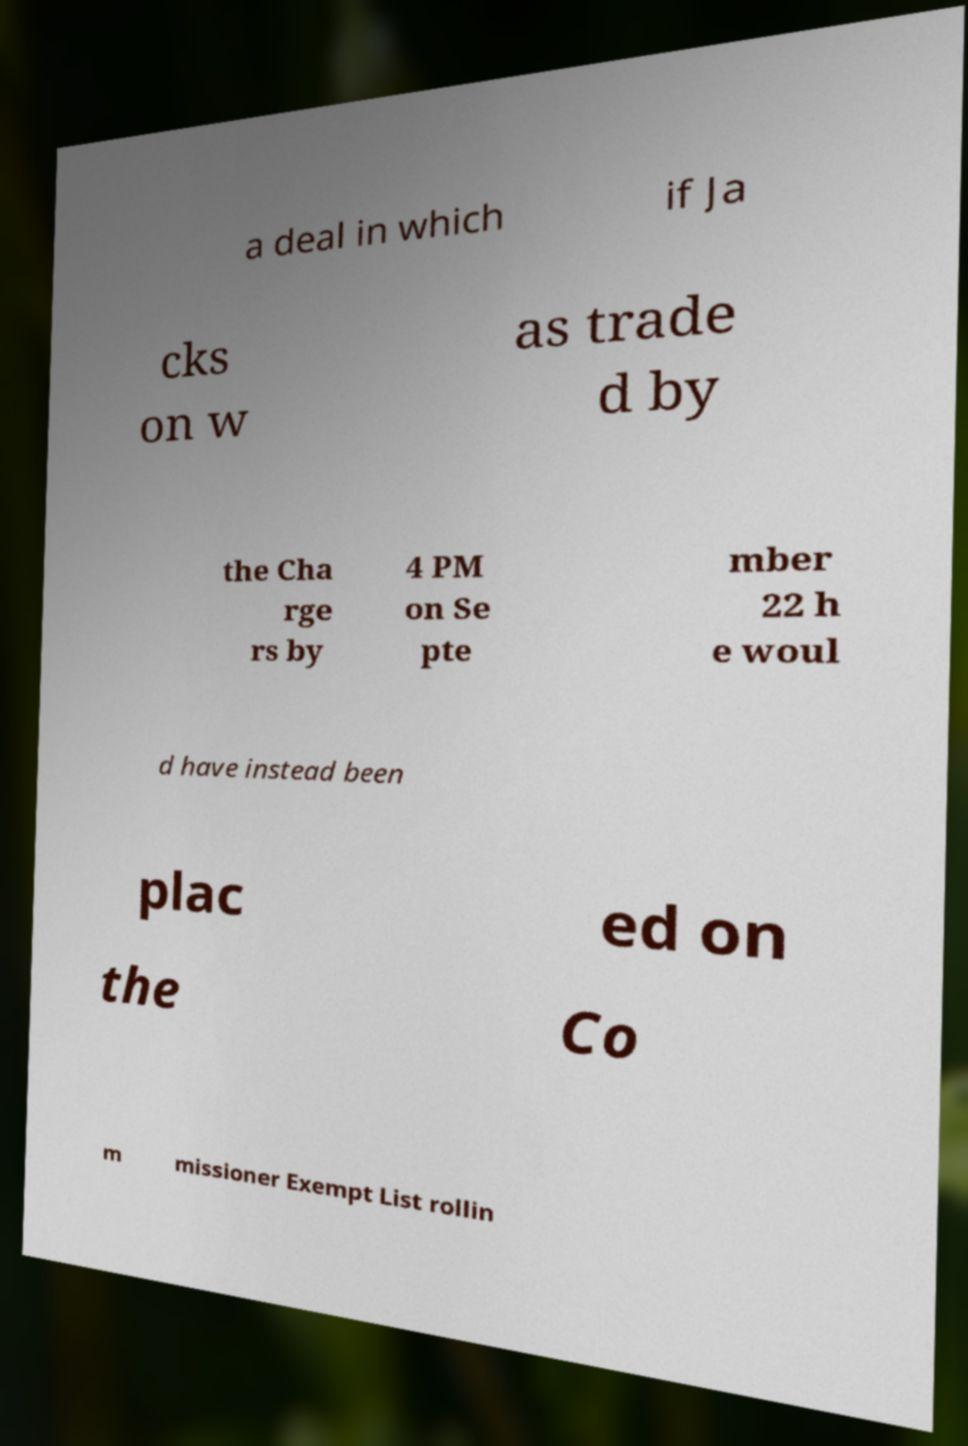I need the written content from this picture converted into text. Can you do that? a deal in which if Ja cks on w as trade d by the Cha rge rs by 4 PM on Se pte mber 22 h e woul d have instead been plac ed on the Co m missioner Exempt List rollin 